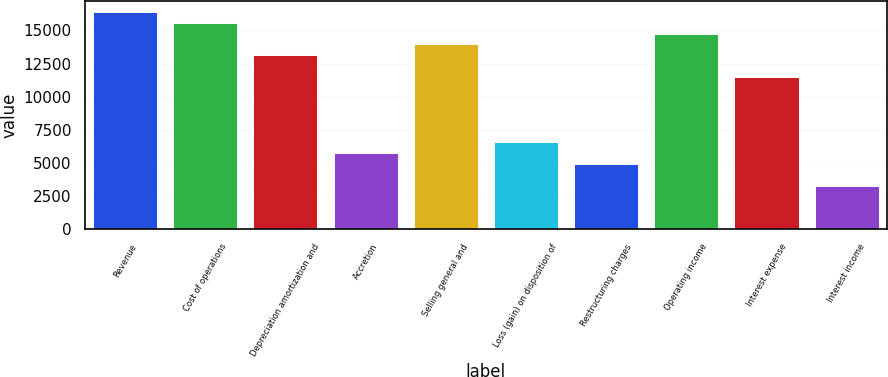Convert chart to OTSL. <chart><loc_0><loc_0><loc_500><loc_500><bar_chart><fcel>Revenue<fcel>Cost of operations<fcel>Depreciation amortization and<fcel>Accretion<fcel>Selling general and<fcel>Loss (gain) on disposition of<fcel>Restructuring charges<fcel>Operating income<fcel>Interest expense<fcel>Interest income<nl><fcel>16397.4<fcel>15577.5<fcel>13118<fcel>5739.57<fcel>13937.9<fcel>6559.4<fcel>4919.74<fcel>14757.7<fcel>11478.4<fcel>3280.08<nl></chart> 